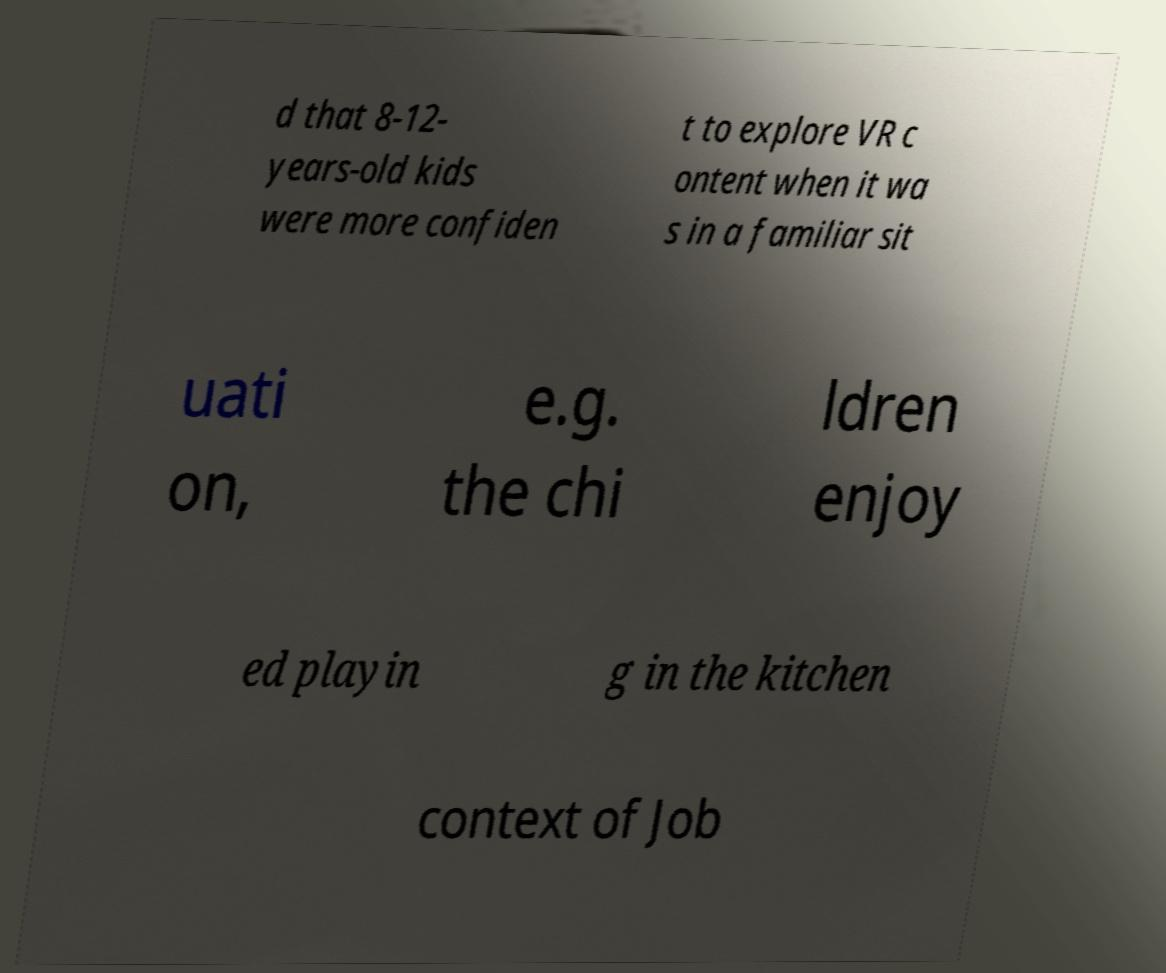Can you read and provide the text displayed in the image?This photo seems to have some interesting text. Can you extract and type it out for me? d that 8-12- years-old kids were more confiden t to explore VR c ontent when it wa s in a familiar sit uati on, e.g. the chi ldren enjoy ed playin g in the kitchen context of Job 